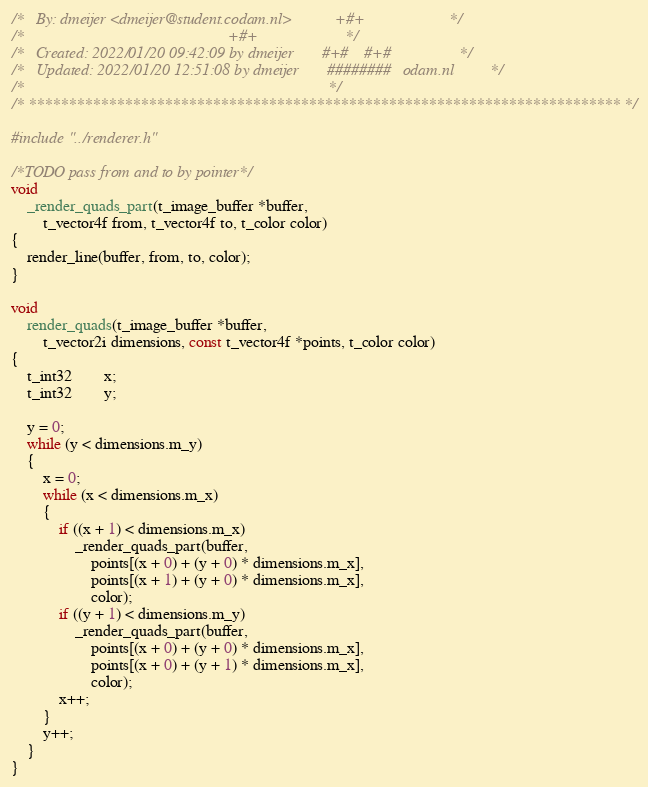<code> <loc_0><loc_0><loc_500><loc_500><_C_>/*   By: dmeijer <dmeijer@student.codam.nl>           +#+                     */
/*                                                   +#+                      */
/*   Created: 2022/01/20 09:42:09 by dmeijer       #+#    #+#                 */
/*   Updated: 2022/01/20 12:51:08 by dmeijer       ########   odam.nl         */
/*                                                                            */
/* ************************************************************************** */

#include "../renderer.h"

/*TODO pass from and to by pointer*/
void
	_render_quads_part(t_image_buffer *buffer,
		t_vector4f from, t_vector4f to, t_color color)
{
	render_line(buffer, from, to, color);
}

void
	render_quads(t_image_buffer *buffer,
		t_vector2i dimensions, const t_vector4f *points, t_color color)
{
	t_int32		x;
	t_int32		y;

	y = 0;
	while (y < dimensions.m_y)
	{
		x = 0;
		while (x < dimensions.m_x)
		{
			if ((x + 1) < dimensions.m_x)
				_render_quads_part(buffer,
					points[(x + 0) + (y + 0) * dimensions.m_x],
					points[(x + 1) + (y + 0) * dimensions.m_x],
					color);
			if ((y + 1) < dimensions.m_y)
				_render_quads_part(buffer,
					points[(x + 0) + (y + 0) * dimensions.m_x],
					points[(x + 0) + (y + 1) * dimensions.m_x],
					color);
			x++;
		}
		y++;
	}	
}
</code> 